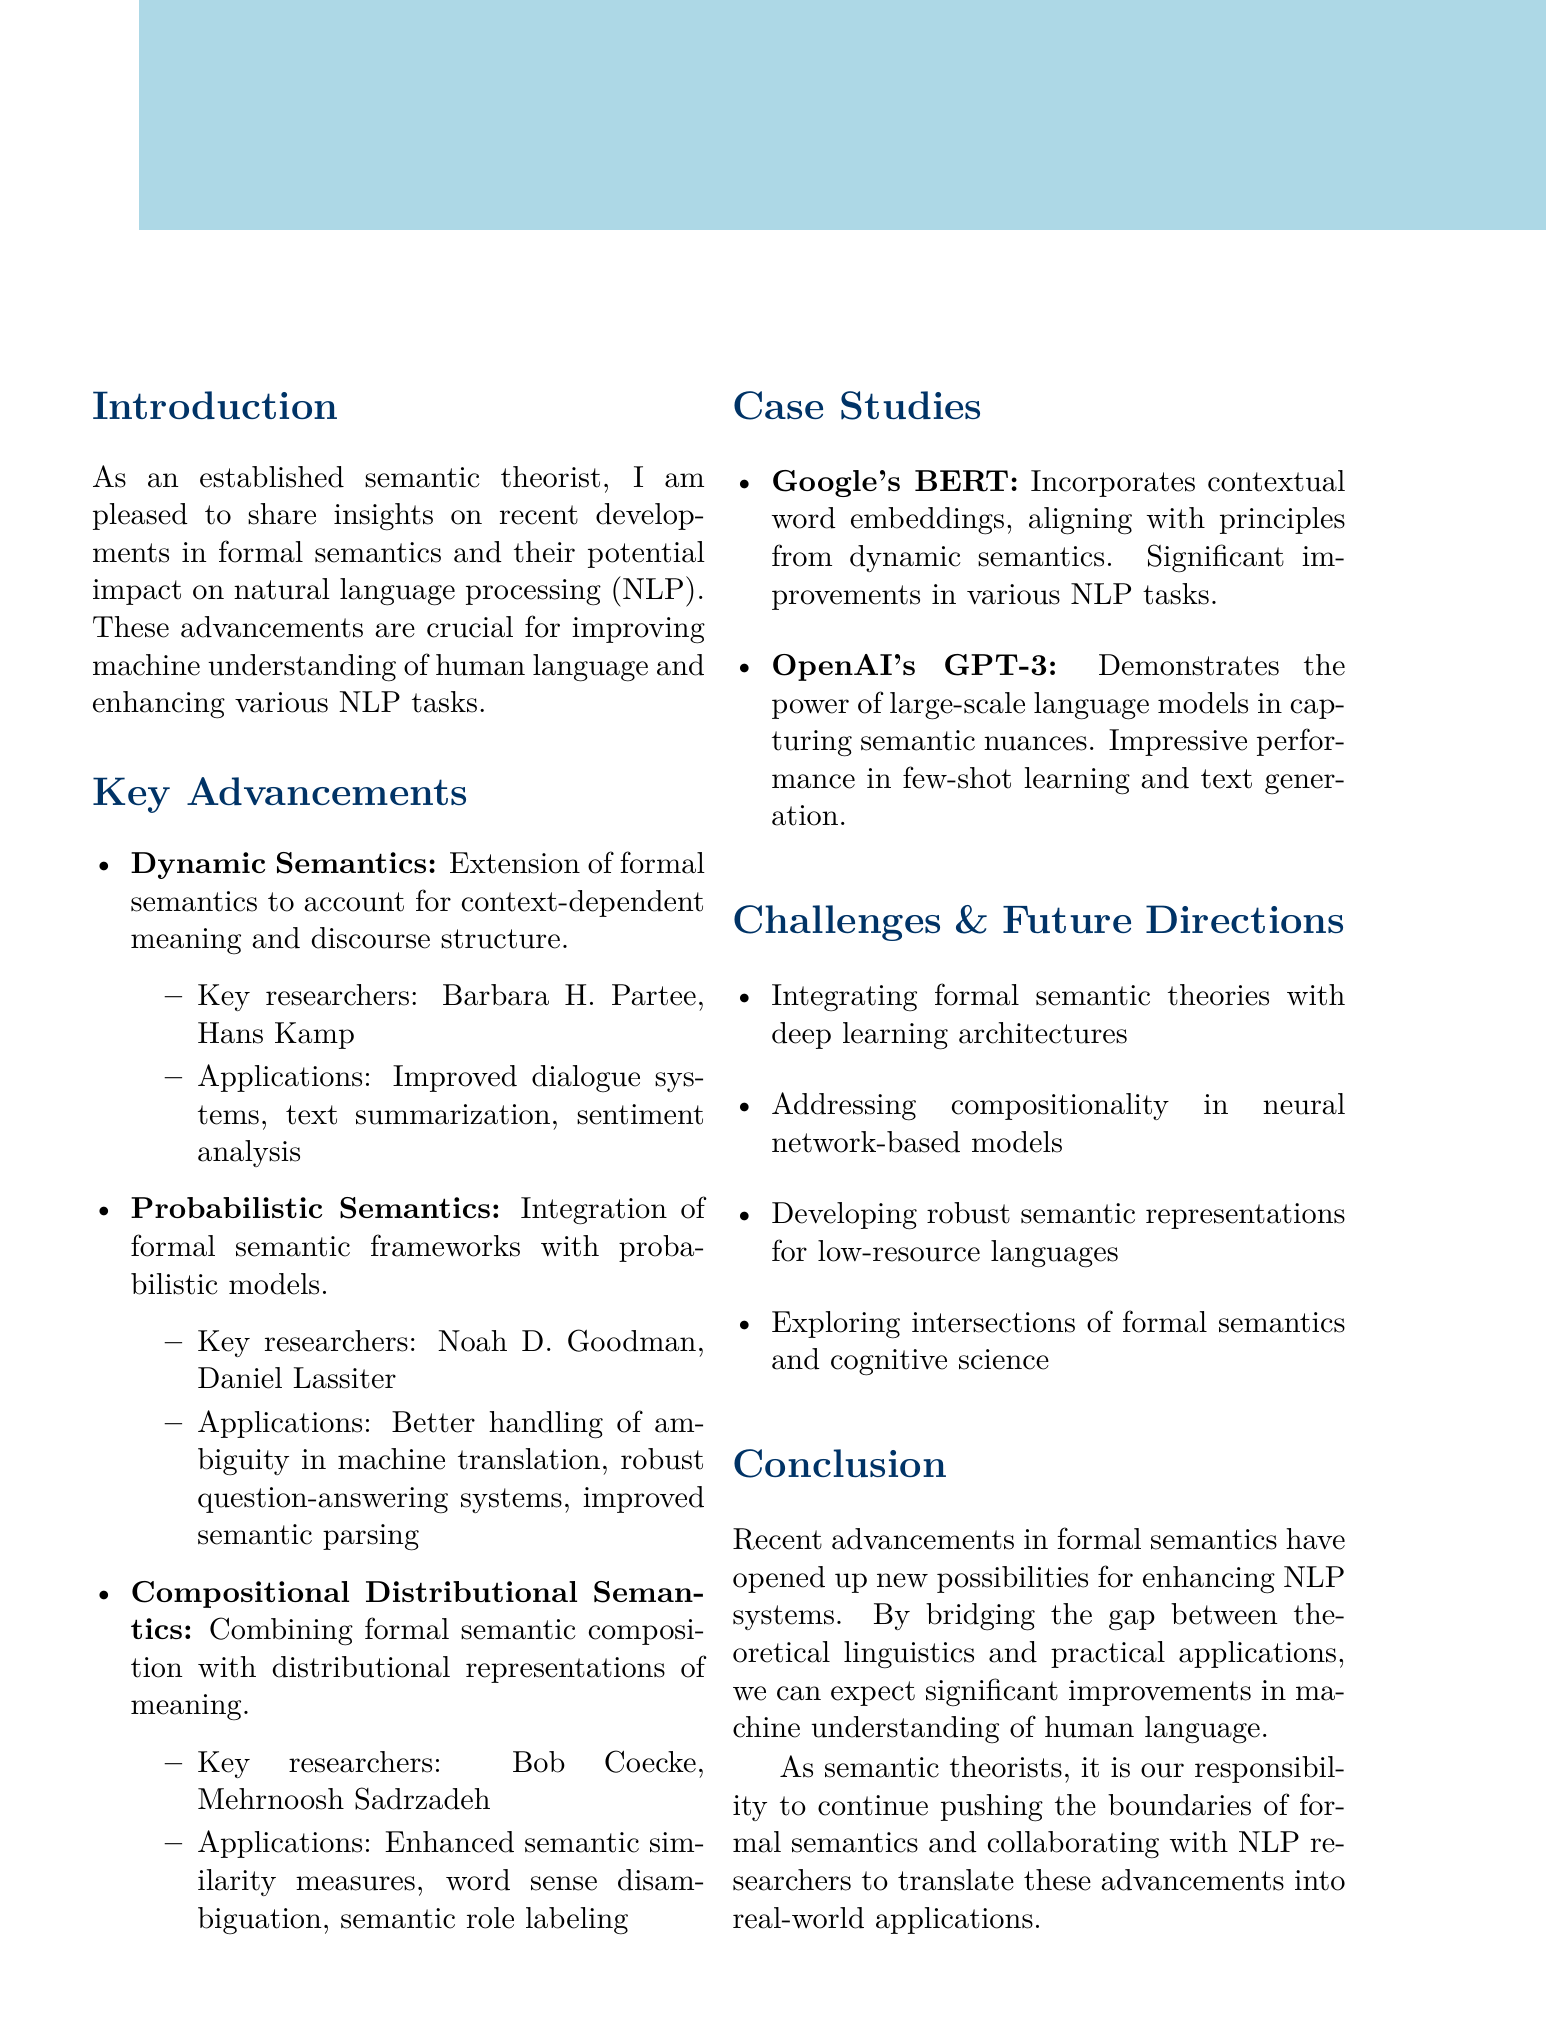What is the title of the memo? The title is clearly stated at the beginning of the document.
Answer: Recent Advancements in Formal Semantics and Their Potential Applications in NLP Who are two key researchers associated with Dynamic Semantics? The document provides a list of key researchers for each advancement.
Answer: Barbara H. Partee, Hans Kamp What is one potential application of Compositional Distributional Semantics? The document lists applications for each semantic advancement.
Answer: Enhanced semantic similarity measures What is the main focus of Probabilistic Semantics? The description of Probabilistic Semantics indicates its general focus.
Answer: Integration of formal semantic frameworks with probabilistic models Which case study demonstrates contextual word embeddings? The case studies mention specific technologies that illustrate advancements.
Answer: Google's BERT What are two challenges mentioned for future directions? The document outlines challenges that need to be addressed for future work.
Answer: Integrating formal semantic theories with deep learning architectures, Addressing compositionality in neural network-based models What is the impact of OpenAI's GPT-3 mentioned in the document? Each case study includes an impact statement describing the results.
Answer: Impressive performance in few-shot learning scenarios and generation of human-like text What is a call to action for semantic theorists? The conclusion includes a call to action related to the advancements discussed.
Answer: Continue pushing the boundaries of formal semantics and collaborating with NLP researchers 